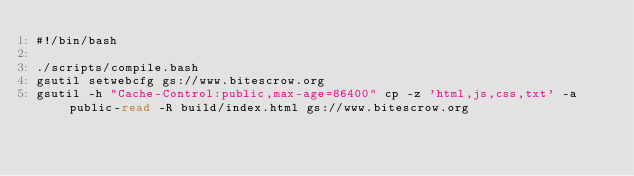<code> <loc_0><loc_0><loc_500><loc_500><_Bash_>#!/bin/bash

./scripts/compile.bash
gsutil setwebcfg gs://www.bitescrow.org
gsutil -h "Cache-Control:public,max-age=86400" cp -z 'html,js,css,txt' -a public-read -R build/index.html gs://www.bitescrow.org
</code> 